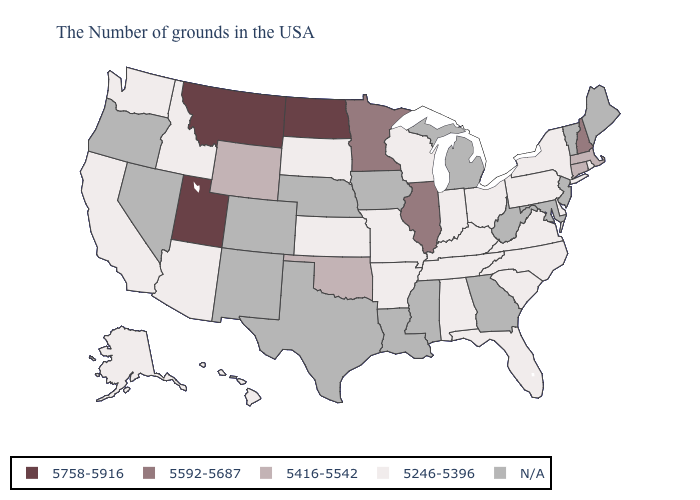Name the states that have a value in the range 5758-5916?
Concise answer only. North Dakota, Utah, Montana. What is the value of Idaho?
Write a very short answer. 5246-5396. What is the value of Ohio?
Quick response, please. 5246-5396. Does the map have missing data?
Short answer required. Yes. Which states have the highest value in the USA?
Quick response, please. North Dakota, Utah, Montana. Name the states that have a value in the range N/A?
Short answer required. Maine, Vermont, New Jersey, Maryland, West Virginia, Georgia, Michigan, Mississippi, Louisiana, Iowa, Nebraska, Texas, Colorado, New Mexico, Nevada, Oregon. What is the highest value in states that border Montana?
Give a very brief answer. 5758-5916. Name the states that have a value in the range 5592-5687?
Concise answer only. New Hampshire, Illinois, Minnesota. How many symbols are there in the legend?
Write a very short answer. 5. Among the states that border Utah , which have the highest value?
Quick response, please. Wyoming. Name the states that have a value in the range 5758-5916?
Quick response, please. North Dakota, Utah, Montana. What is the highest value in states that border Arkansas?
Keep it brief. 5416-5542. Does Montana have the highest value in the USA?
Give a very brief answer. Yes. 